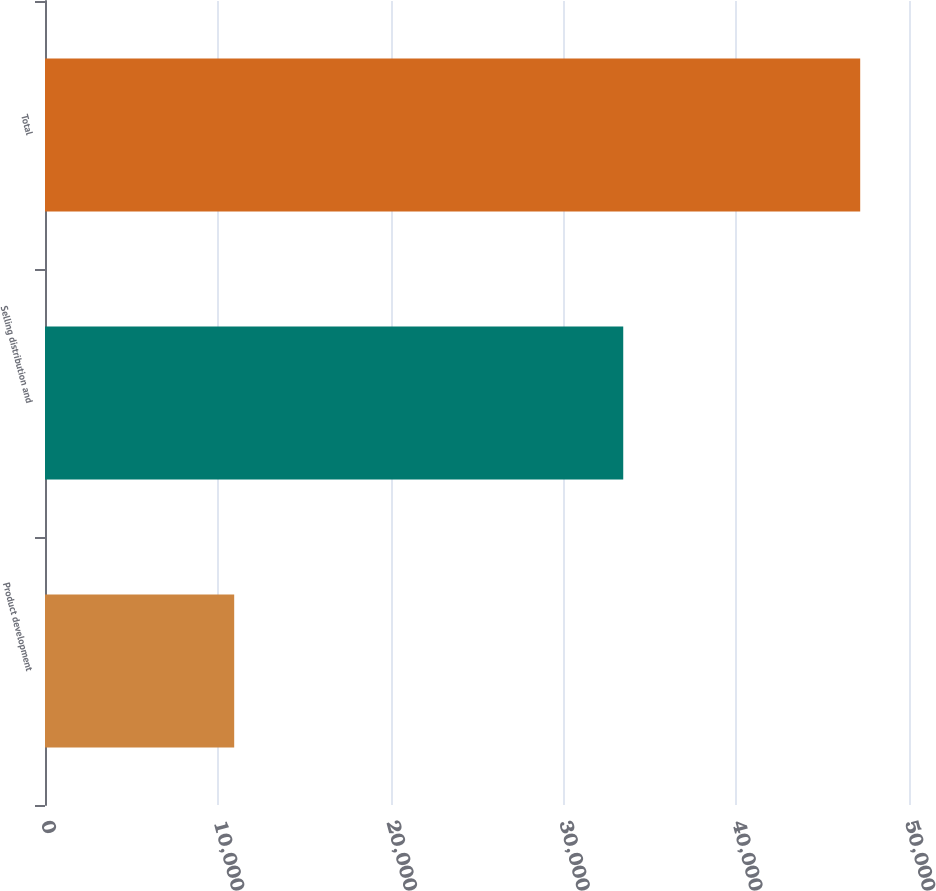<chart> <loc_0><loc_0><loc_500><loc_500><bar_chart><fcel>Product development<fcel>Selling distribution and<fcel>Total<nl><fcel>10949<fcel>33463<fcel>47176<nl></chart> 